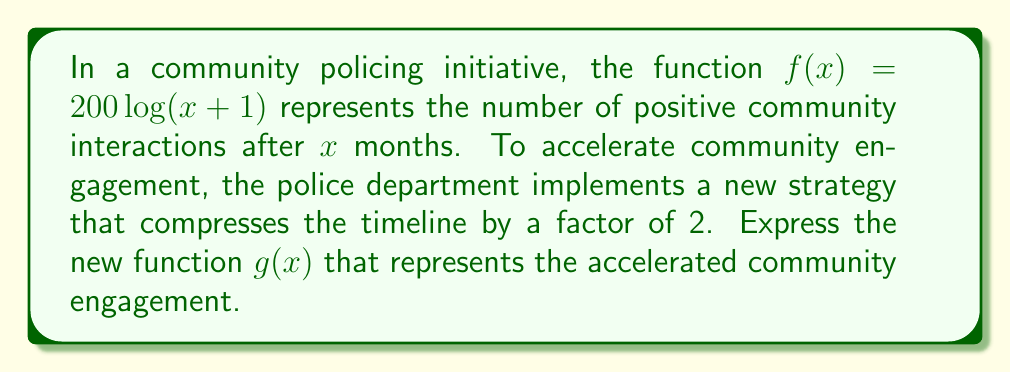Solve this math problem. To solve this problem, we need to apply a horizontal compression to the original function $f(x)$. The process is as follows:

1) The general form of a horizontal compression is $g(x) = f(bx)$, where $b > 1$ represents the compression factor.

2) In this case, we want to compress the timeline by a factor of 2, which means events that previously took $x$ months now take $\frac{x}{2}$ months. This corresponds to $b = 2$.

3) Therefore, we replace $x$ with $2x$ in the original function:

   $g(x) = f(2x) = 200 \log((2x)+1)$

4) Simplify the expression inside the parentheses:

   $g(x) = 200 \log(2x+1)$

This new function $g(x)$ represents the accelerated community engagement, where the same level of engagement is achieved in half the time compared to the original function $f(x)$.
Answer: $g(x) = 200 \log(2x+1)$ 